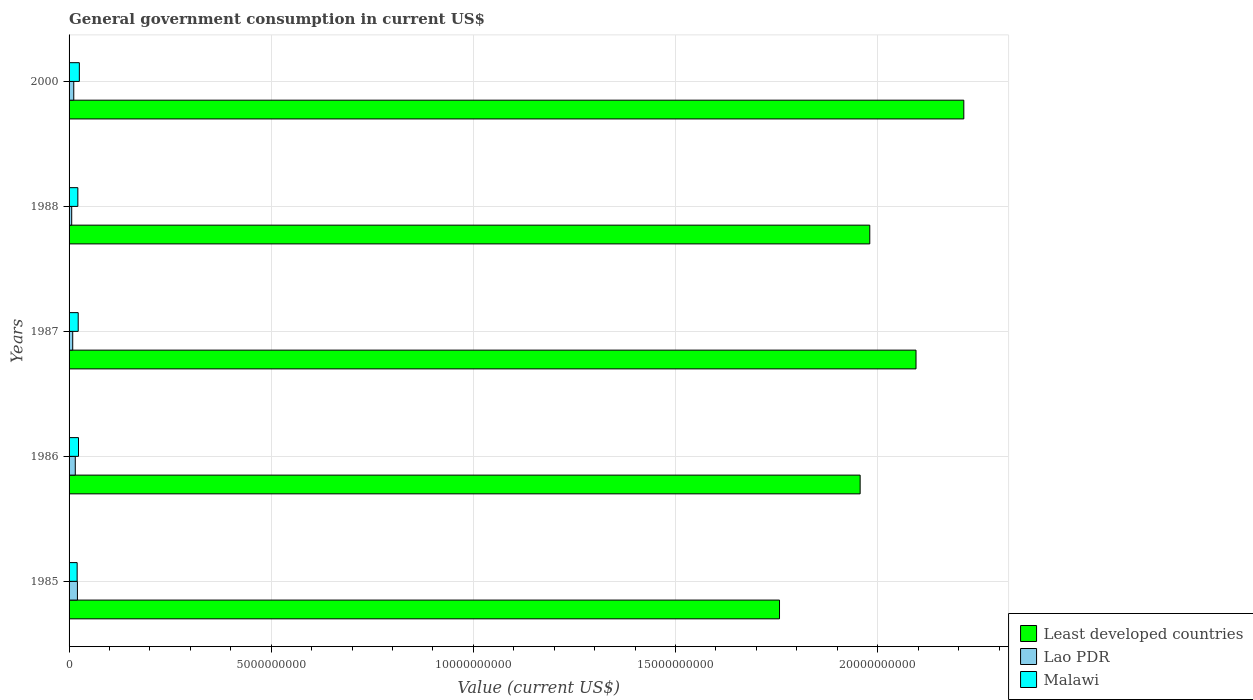How many different coloured bars are there?
Keep it short and to the point. 3. How many groups of bars are there?
Make the answer very short. 5. How many bars are there on the 1st tick from the bottom?
Keep it short and to the point. 3. In how many cases, is the number of bars for a given year not equal to the number of legend labels?
Your answer should be very brief. 0. What is the government conusmption in Least developed countries in 1985?
Offer a terse response. 1.76e+1. Across all years, what is the maximum government conusmption in Least developed countries?
Make the answer very short. 2.21e+1. Across all years, what is the minimum government conusmption in Lao PDR?
Provide a succinct answer. 6.50e+07. What is the total government conusmption in Malawi in the graph?
Your answer should be very brief. 1.13e+09. What is the difference between the government conusmption in Lao PDR in 1986 and that in 1988?
Offer a very short reply. 8.86e+07. What is the difference between the government conusmption in Malawi in 2000 and the government conusmption in Lao PDR in 1986?
Offer a terse response. 1.00e+08. What is the average government conusmption in Malawi per year?
Your answer should be very brief. 2.26e+08. In the year 1988, what is the difference between the government conusmption in Malawi and government conusmption in Least developed countries?
Keep it short and to the point. -1.96e+1. What is the ratio of the government conusmption in Lao PDR in 1986 to that in 1988?
Give a very brief answer. 2.36. What is the difference between the highest and the second highest government conusmption in Malawi?
Offer a very short reply. 2.11e+07. What is the difference between the highest and the lowest government conusmption in Malawi?
Your answer should be very brief. 5.41e+07. In how many years, is the government conusmption in Lao PDR greater than the average government conusmption in Lao PDR taken over all years?
Your response must be concise. 2. What does the 2nd bar from the top in 1988 represents?
Ensure brevity in your answer.  Lao PDR. What does the 1st bar from the bottom in 1987 represents?
Offer a very short reply. Least developed countries. Are all the bars in the graph horizontal?
Your answer should be compact. Yes. How many years are there in the graph?
Ensure brevity in your answer.  5. Does the graph contain any zero values?
Provide a short and direct response. No. Does the graph contain grids?
Keep it short and to the point. Yes. What is the title of the graph?
Make the answer very short. General government consumption in current US$. Does "World" appear as one of the legend labels in the graph?
Offer a terse response. No. What is the label or title of the X-axis?
Make the answer very short. Value (current US$). What is the label or title of the Y-axis?
Your answer should be compact. Years. What is the Value (current US$) of Least developed countries in 1985?
Provide a succinct answer. 1.76e+1. What is the Value (current US$) in Lao PDR in 1985?
Provide a short and direct response. 2.07e+08. What is the Value (current US$) of Malawi in 1985?
Your response must be concise. 2.00e+08. What is the Value (current US$) in Least developed countries in 1986?
Provide a short and direct response. 1.96e+1. What is the Value (current US$) of Lao PDR in 1986?
Give a very brief answer. 1.54e+08. What is the Value (current US$) in Malawi in 1986?
Your answer should be compact. 2.33e+08. What is the Value (current US$) of Least developed countries in 1987?
Your answer should be compact. 2.09e+1. What is the Value (current US$) of Lao PDR in 1987?
Keep it short and to the point. 9.02e+07. What is the Value (current US$) in Malawi in 1987?
Make the answer very short. 2.26e+08. What is the Value (current US$) of Least developed countries in 1988?
Provide a short and direct response. 1.98e+1. What is the Value (current US$) in Lao PDR in 1988?
Ensure brevity in your answer.  6.50e+07. What is the Value (current US$) of Malawi in 1988?
Offer a very short reply. 2.17e+08. What is the Value (current US$) in Least developed countries in 2000?
Ensure brevity in your answer.  2.21e+1. What is the Value (current US$) in Lao PDR in 2000?
Make the answer very short. 1.16e+08. What is the Value (current US$) of Malawi in 2000?
Keep it short and to the point. 2.54e+08. Across all years, what is the maximum Value (current US$) in Least developed countries?
Your answer should be very brief. 2.21e+1. Across all years, what is the maximum Value (current US$) in Lao PDR?
Your answer should be compact. 2.07e+08. Across all years, what is the maximum Value (current US$) in Malawi?
Make the answer very short. 2.54e+08. Across all years, what is the minimum Value (current US$) of Least developed countries?
Provide a succinct answer. 1.76e+1. Across all years, what is the minimum Value (current US$) in Lao PDR?
Your answer should be very brief. 6.50e+07. Across all years, what is the minimum Value (current US$) of Malawi?
Give a very brief answer. 2.00e+08. What is the total Value (current US$) of Least developed countries in the graph?
Your answer should be compact. 1.00e+11. What is the total Value (current US$) in Lao PDR in the graph?
Ensure brevity in your answer.  6.32e+08. What is the total Value (current US$) in Malawi in the graph?
Give a very brief answer. 1.13e+09. What is the difference between the Value (current US$) in Least developed countries in 1985 and that in 1986?
Give a very brief answer. -1.99e+09. What is the difference between the Value (current US$) in Lao PDR in 1985 and that in 1986?
Your answer should be very brief. 5.30e+07. What is the difference between the Value (current US$) of Malawi in 1985 and that in 1986?
Your answer should be compact. -3.30e+07. What is the difference between the Value (current US$) in Least developed countries in 1985 and that in 1987?
Your answer should be very brief. -3.38e+09. What is the difference between the Value (current US$) in Lao PDR in 1985 and that in 1987?
Provide a short and direct response. 1.16e+08. What is the difference between the Value (current US$) of Malawi in 1985 and that in 1987?
Your answer should be very brief. -2.59e+07. What is the difference between the Value (current US$) of Least developed countries in 1985 and that in 1988?
Your answer should be compact. -2.23e+09. What is the difference between the Value (current US$) in Lao PDR in 1985 and that in 1988?
Offer a terse response. 1.42e+08. What is the difference between the Value (current US$) in Malawi in 1985 and that in 1988?
Your answer should be very brief. -1.67e+07. What is the difference between the Value (current US$) of Least developed countries in 1985 and that in 2000?
Your response must be concise. -4.56e+09. What is the difference between the Value (current US$) of Lao PDR in 1985 and that in 2000?
Keep it short and to the point. 9.05e+07. What is the difference between the Value (current US$) in Malawi in 1985 and that in 2000?
Your response must be concise. -5.41e+07. What is the difference between the Value (current US$) in Least developed countries in 1986 and that in 1987?
Keep it short and to the point. -1.38e+09. What is the difference between the Value (current US$) of Lao PDR in 1986 and that in 1987?
Keep it short and to the point. 6.35e+07. What is the difference between the Value (current US$) of Malawi in 1986 and that in 1987?
Provide a short and direct response. 7.08e+06. What is the difference between the Value (current US$) in Least developed countries in 1986 and that in 1988?
Your answer should be compact. -2.38e+08. What is the difference between the Value (current US$) in Lao PDR in 1986 and that in 1988?
Your answer should be very brief. 8.86e+07. What is the difference between the Value (current US$) in Malawi in 1986 and that in 1988?
Offer a very short reply. 1.63e+07. What is the difference between the Value (current US$) in Least developed countries in 1986 and that in 2000?
Ensure brevity in your answer.  -2.56e+09. What is the difference between the Value (current US$) of Lao PDR in 1986 and that in 2000?
Your response must be concise. 3.75e+07. What is the difference between the Value (current US$) in Malawi in 1986 and that in 2000?
Give a very brief answer. -2.11e+07. What is the difference between the Value (current US$) of Least developed countries in 1987 and that in 1988?
Ensure brevity in your answer.  1.14e+09. What is the difference between the Value (current US$) in Lao PDR in 1987 and that in 1988?
Keep it short and to the point. 2.52e+07. What is the difference between the Value (current US$) of Malawi in 1987 and that in 1988?
Offer a very short reply. 9.21e+06. What is the difference between the Value (current US$) of Least developed countries in 1987 and that in 2000?
Provide a succinct answer. -1.18e+09. What is the difference between the Value (current US$) of Lao PDR in 1987 and that in 2000?
Your response must be concise. -2.59e+07. What is the difference between the Value (current US$) of Malawi in 1987 and that in 2000?
Your answer should be very brief. -2.82e+07. What is the difference between the Value (current US$) in Least developed countries in 1988 and that in 2000?
Your response must be concise. -2.33e+09. What is the difference between the Value (current US$) of Lao PDR in 1988 and that in 2000?
Your answer should be very brief. -5.11e+07. What is the difference between the Value (current US$) in Malawi in 1988 and that in 2000?
Make the answer very short. -3.74e+07. What is the difference between the Value (current US$) of Least developed countries in 1985 and the Value (current US$) of Lao PDR in 1986?
Provide a succinct answer. 1.74e+1. What is the difference between the Value (current US$) of Least developed countries in 1985 and the Value (current US$) of Malawi in 1986?
Your answer should be compact. 1.73e+1. What is the difference between the Value (current US$) of Lao PDR in 1985 and the Value (current US$) of Malawi in 1986?
Your answer should be compact. -2.64e+07. What is the difference between the Value (current US$) of Least developed countries in 1985 and the Value (current US$) of Lao PDR in 1987?
Provide a short and direct response. 1.75e+1. What is the difference between the Value (current US$) in Least developed countries in 1985 and the Value (current US$) in Malawi in 1987?
Your response must be concise. 1.73e+1. What is the difference between the Value (current US$) of Lao PDR in 1985 and the Value (current US$) of Malawi in 1987?
Your response must be concise. -1.93e+07. What is the difference between the Value (current US$) of Least developed countries in 1985 and the Value (current US$) of Lao PDR in 1988?
Your response must be concise. 1.75e+1. What is the difference between the Value (current US$) of Least developed countries in 1985 and the Value (current US$) of Malawi in 1988?
Keep it short and to the point. 1.74e+1. What is the difference between the Value (current US$) of Lao PDR in 1985 and the Value (current US$) of Malawi in 1988?
Offer a very short reply. -1.01e+07. What is the difference between the Value (current US$) of Least developed countries in 1985 and the Value (current US$) of Lao PDR in 2000?
Your response must be concise. 1.75e+1. What is the difference between the Value (current US$) of Least developed countries in 1985 and the Value (current US$) of Malawi in 2000?
Ensure brevity in your answer.  1.73e+1. What is the difference between the Value (current US$) in Lao PDR in 1985 and the Value (current US$) in Malawi in 2000?
Keep it short and to the point. -4.75e+07. What is the difference between the Value (current US$) of Least developed countries in 1986 and the Value (current US$) of Lao PDR in 1987?
Offer a very short reply. 1.95e+1. What is the difference between the Value (current US$) of Least developed countries in 1986 and the Value (current US$) of Malawi in 1987?
Make the answer very short. 1.93e+1. What is the difference between the Value (current US$) in Lao PDR in 1986 and the Value (current US$) in Malawi in 1987?
Your answer should be compact. -7.23e+07. What is the difference between the Value (current US$) in Least developed countries in 1986 and the Value (current US$) in Lao PDR in 1988?
Your answer should be compact. 1.95e+1. What is the difference between the Value (current US$) of Least developed countries in 1986 and the Value (current US$) of Malawi in 1988?
Give a very brief answer. 1.93e+1. What is the difference between the Value (current US$) in Lao PDR in 1986 and the Value (current US$) in Malawi in 1988?
Ensure brevity in your answer.  -6.31e+07. What is the difference between the Value (current US$) of Least developed countries in 1986 and the Value (current US$) of Lao PDR in 2000?
Provide a succinct answer. 1.94e+1. What is the difference between the Value (current US$) of Least developed countries in 1986 and the Value (current US$) of Malawi in 2000?
Your answer should be compact. 1.93e+1. What is the difference between the Value (current US$) of Lao PDR in 1986 and the Value (current US$) of Malawi in 2000?
Provide a short and direct response. -1.00e+08. What is the difference between the Value (current US$) of Least developed countries in 1987 and the Value (current US$) of Lao PDR in 1988?
Offer a terse response. 2.09e+1. What is the difference between the Value (current US$) in Least developed countries in 1987 and the Value (current US$) in Malawi in 1988?
Provide a short and direct response. 2.07e+1. What is the difference between the Value (current US$) in Lao PDR in 1987 and the Value (current US$) in Malawi in 1988?
Offer a very short reply. -1.27e+08. What is the difference between the Value (current US$) in Least developed countries in 1987 and the Value (current US$) in Lao PDR in 2000?
Give a very brief answer. 2.08e+1. What is the difference between the Value (current US$) in Least developed countries in 1987 and the Value (current US$) in Malawi in 2000?
Make the answer very short. 2.07e+1. What is the difference between the Value (current US$) in Lao PDR in 1987 and the Value (current US$) in Malawi in 2000?
Give a very brief answer. -1.64e+08. What is the difference between the Value (current US$) of Least developed countries in 1988 and the Value (current US$) of Lao PDR in 2000?
Provide a succinct answer. 1.97e+1. What is the difference between the Value (current US$) in Least developed countries in 1988 and the Value (current US$) in Malawi in 2000?
Keep it short and to the point. 1.95e+1. What is the difference between the Value (current US$) of Lao PDR in 1988 and the Value (current US$) of Malawi in 2000?
Give a very brief answer. -1.89e+08. What is the average Value (current US$) of Least developed countries per year?
Ensure brevity in your answer.  2.00e+1. What is the average Value (current US$) of Lao PDR per year?
Provide a succinct answer. 1.26e+08. What is the average Value (current US$) of Malawi per year?
Your answer should be very brief. 2.26e+08. In the year 1985, what is the difference between the Value (current US$) in Least developed countries and Value (current US$) in Lao PDR?
Your response must be concise. 1.74e+1. In the year 1985, what is the difference between the Value (current US$) of Least developed countries and Value (current US$) of Malawi?
Provide a succinct answer. 1.74e+1. In the year 1985, what is the difference between the Value (current US$) in Lao PDR and Value (current US$) in Malawi?
Offer a very short reply. 6.56e+06. In the year 1986, what is the difference between the Value (current US$) of Least developed countries and Value (current US$) of Lao PDR?
Offer a terse response. 1.94e+1. In the year 1986, what is the difference between the Value (current US$) of Least developed countries and Value (current US$) of Malawi?
Offer a very short reply. 1.93e+1. In the year 1986, what is the difference between the Value (current US$) of Lao PDR and Value (current US$) of Malawi?
Provide a succinct answer. -7.94e+07. In the year 1987, what is the difference between the Value (current US$) of Least developed countries and Value (current US$) of Lao PDR?
Provide a short and direct response. 2.09e+1. In the year 1987, what is the difference between the Value (current US$) in Least developed countries and Value (current US$) in Malawi?
Provide a short and direct response. 2.07e+1. In the year 1987, what is the difference between the Value (current US$) of Lao PDR and Value (current US$) of Malawi?
Your answer should be very brief. -1.36e+08. In the year 1988, what is the difference between the Value (current US$) of Least developed countries and Value (current US$) of Lao PDR?
Make the answer very short. 1.97e+1. In the year 1988, what is the difference between the Value (current US$) in Least developed countries and Value (current US$) in Malawi?
Your answer should be compact. 1.96e+1. In the year 1988, what is the difference between the Value (current US$) in Lao PDR and Value (current US$) in Malawi?
Offer a terse response. -1.52e+08. In the year 2000, what is the difference between the Value (current US$) of Least developed countries and Value (current US$) of Lao PDR?
Ensure brevity in your answer.  2.20e+1. In the year 2000, what is the difference between the Value (current US$) of Least developed countries and Value (current US$) of Malawi?
Ensure brevity in your answer.  2.19e+1. In the year 2000, what is the difference between the Value (current US$) in Lao PDR and Value (current US$) in Malawi?
Ensure brevity in your answer.  -1.38e+08. What is the ratio of the Value (current US$) of Least developed countries in 1985 to that in 1986?
Provide a succinct answer. 0.9. What is the ratio of the Value (current US$) in Lao PDR in 1985 to that in 1986?
Provide a succinct answer. 1.34. What is the ratio of the Value (current US$) in Malawi in 1985 to that in 1986?
Ensure brevity in your answer.  0.86. What is the ratio of the Value (current US$) in Least developed countries in 1985 to that in 1987?
Provide a short and direct response. 0.84. What is the ratio of the Value (current US$) of Lao PDR in 1985 to that in 1987?
Ensure brevity in your answer.  2.29. What is the ratio of the Value (current US$) of Malawi in 1985 to that in 1987?
Your answer should be very brief. 0.89. What is the ratio of the Value (current US$) of Least developed countries in 1985 to that in 1988?
Make the answer very short. 0.89. What is the ratio of the Value (current US$) in Lao PDR in 1985 to that in 1988?
Make the answer very short. 3.18. What is the ratio of the Value (current US$) in Malawi in 1985 to that in 1988?
Offer a terse response. 0.92. What is the ratio of the Value (current US$) in Least developed countries in 1985 to that in 2000?
Provide a succinct answer. 0.79. What is the ratio of the Value (current US$) in Lao PDR in 1985 to that in 2000?
Make the answer very short. 1.78. What is the ratio of the Value (current US$) of Malawi in 1985 to that in 2000?
Provide a short and direct response. 0.79. What is the ratio of the Value (current US$) of Least developed countries in 1986 to that in 1987?
Your answer should be very brief. 0.93. What is the ratio of the Value (current US$) of Lao PDR in 1986 to that in 1987?
Provide a short and direct response. 1.7. What is the ratio of the Value (current US$) of Malawi in 1986 to that in 1987?
Your answer should be very brief. 1.03. What is the ratio of the Value (current US$) of Lao PDR in 1986 to that in 1988?
Provide a short and direct response. 2.36. What is the ratio of the Value (current US$) of Malawi in 1986 to that in 1988?
Your answer should be very brief. 1.08. What is the ratio of the Value (current US$) in Least developed countries in 1986 to that in 2000?
Give a very brief answer. 0.88. What is the ratio of the Value (current US$) in Lao PDR in 1986 to that in 2000?
Keep it short and to the point. 1.32. What is the ratio of the Value (current US$) in Malawi in 1986 to that in 2000?
Provide a short and direct response. 0.92. What is the ratio of the Value (current US$) of Least developed countries in 1987 to that in 1988?
Provide a succinct answer. 1.06. What is the ratio of the Value (current US$) in Lao PDR in 1987 to that in 1988?
Your response must be concise. 1.39. What is the ratio of the Value (current US$) of Malawi in 1987 to that in 1988?
Offer a terse response. 1.04. What is the ratio of the Value (current US$) in Least developed countries in 1987 to that in 2000?
Offer a terse response. 0.95. What is the ratio of the Value (current US$) in Lao PDR in 1987 to that in 2000?
Your response must be concise. 0.78. What is the ratio of the Value (current US$) in Malawi in 1987 to that in 2000?
Your answer should be compact. 0.89. What is the ratio of the Value (current US$) in Least developed countries in 1988 to that in 2000?
Provide a short and direct response. 0.89. What is the ratio of the Value (current US$) of Lao PDR in 1988 to that in 2000?
Ensure brevity in your answer.  0.56. What is the ratio of the Value (current US$) in Malawi in 1988 to that in 2000?
Keep it short and to the point. 0.85. What is the difference between the highest and the second highest Value (current US$) of Least developed countries?
Your answer should be very brief. 1.18e+09. What is the difference between the highest and the second highest Value (current US$) in Lao PDR?
Provide a short and direct response. 5.30e+07. What is the difference between the highest and the second highest Value (current US$) of Malawi?
Offer a terse response. 2.11e+07. What is the difference between the highest and the lowest Value (current US$) in Least developed countries?
Offer a terse response. 4.56e+09. What is the difference between the highest and the lowest Value (current US$) in Lao PDR?
Your answer should be compact. 1.42e+08. What is the difference between the highest and the lowest Value (current US$) of Malawi?
Make the answer very short. 5.41e+07. 